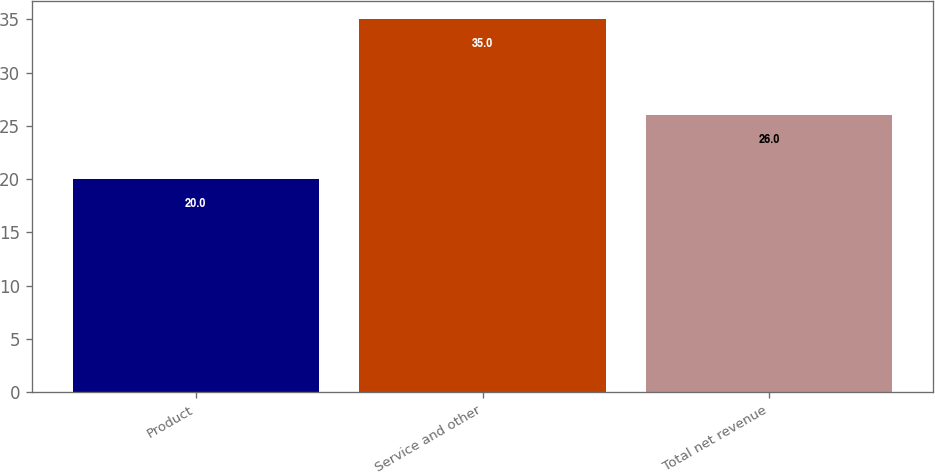<chart> <loc_0><loc_0><loc_500><loc_500><bar_chart><fcel>Product<fcel>Service and other<fcel>Total net revenue<nl><fcel>20<fcel>35<fcel>26<nl></chart> 